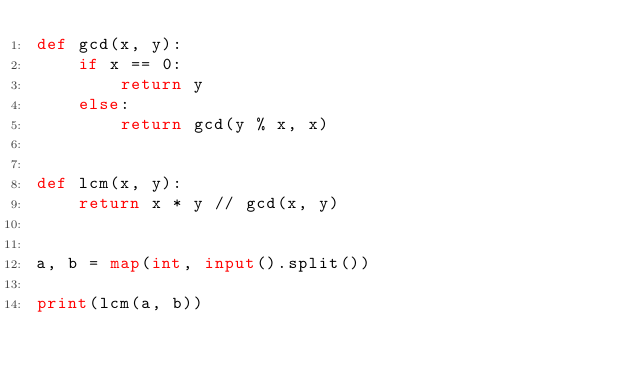Convert code to text. <code><loc_0><loc_0><loc_500><loc_500><_Python_>def gcd(x, y):
    if x == 0:
        return y
    else:
        return gcd(y % x, x)


def lcm(x, y):
    return x * y // gcd(x, y)


a, b = map(int, input().split())

print(lcm(a, b))

</code> 